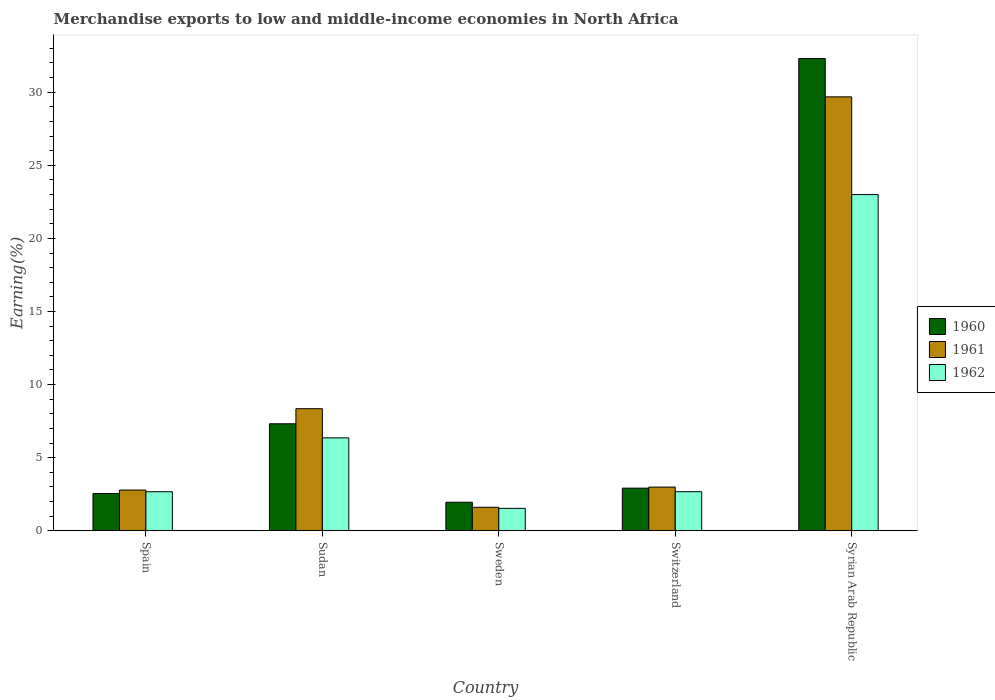How many groups of bars are there?
Provide a succinct answer. 5. Are the number of bars per tick equal to the number of legend labels?
Provide a succinct answer. Yes. Are the number of bars on each tick of the X-axis equal?
Provide a succinct answer. Yes. How many bars are there on the 3rd tick from the left?
Provide a short and direct response. 3. What is the label of the 5th group of bars from the left?
Provide a succinct answer. Syrian Arab Republic. In how many cases, is the number of bars for a given country not equal to the number of legend labels?
Ensure brevity in your answer.  0. What is the percentage of amount earned from merchandise exports in 1961 in Sweden?
Keep it short and to the point. 1.61. Across all countries, what is the maximum percentage of amount earned from merchandise exports in 1962?
Provide a succinct answer. 23. Across all countries, what is the minimum percentage of amount earned from merchandise exports in 1962?
Give a very brief answer. 1.53. In which country was the percentage of amount earned from merchandise exports in 1962 maximum?
Provide a short and direct response. Syrian Arab Republic. In which country was the percentage of amount earned from merchandise exports in 1962 minimum?
Your answer should be very brief. Sweden. What is the total percentage of amount earned from merchandise exports in 1962 in the graph?
Your response must be concise. 36.23. What is the difference between the percentage of amount earned from merchandise exports in 1960 in Sudan and that in Switzerland?
Provide a succinct answer. 4.4. What is the difference between the percentage of amount earned from merchandise exports in 1962 in Spain and the percentage of amount earned from merchandise exports in 1960 in Sweden?
Give a very brief answer. 0.72. What is the average percentage of amount earned from merchandise exports in 1962 per country?
Make the answer very short. 7.25. What is the difference between the percentage of amount earned from merchandise exports of/in 1962 and percentage of amount earned from merchandise exports of/in 1960 in Syrian Arab Republic?
Ensure brevity in your answer.  -9.31. What is the ratio of the percentage of amount earned from merchandise exports in 1961 in Sudan to that in Syrian Arab Republic?
Keep it short and to the point. 0.28. Is the percentage of amount earned from merchandise exports in 1960 in Switzerland less than that in Syrian Arab Republic?
Make the answer very short. Yes. What is the difference between the highest and the second highest percentage of amount earned from merchandise exports in 1962?
Offer a very short reply. -20.32. What is the difference between the highest and the lowest percentage of amount earned from merchandise exports in 1961?
Make the answer very short. 28.07. How many bars are there?
Offer a terse response. 15. Are all the bars in the graph horizontal?
Your answer should be very brief. No. Are the values on the major ticks of Y-axis written in scientific E-notation?
Make the answer very short. No. Does the graph contain any zero values?
Provide a succinct answer. No. How are the legend labels stacked?
Your answer should be very brief. Vertical. What is the title of the graph?
Provide a short and direct response. Merchandise exports to low and middle-income economies in North Africa. What is the label or title of the Y-axis?
Your response must be concise. Earning(%). What is the Earning(%) of 1960 in Spain?
Give a very brief answer. 2.55. What is the Earning(%) of 1961 in Spain?
Offer a very short reply. 2.79. What is the Earning(%) of 1962 in Spain?
Offer a terse response. 2.67. What is the Earning(%) of 1960 in Sudan?
Offer a terse response. 7.32. What is the Earning(%) of 1961 in Sudan?
Provide a succinct answer. 8.35. What is the Earning(%) of 1962 in Sudan?
Ensure brevity in your answer.  6.35. What is the Earning(%) in 1960 in Sweden?
Ensure brevity in your answer.  1.95. What is the Earning(%) in 1961 in Sweden?
Provide a succinct answer. 1.61. What is the Earning(%) of 1962 in Sweden?
Your response must be concise. 1.53. What is the Earning(%) in 1960 in Switzerland?
Offer a very short reply. 2.92. What is the Earning(%) of 1961 in Switzerland?
Offer a terse response. 2.99. What is the Earning(%) in 1962 in Switzerland?
Your response must be concise. 2.67. What is the Earning(%) in 1960 in Syrian Arab Republic?
Ensure brevity in your answer.  32.31. What is the Earning(%) of 1961 in Syrian Arab Republic?
Your answer should be very brief. 29.68. What is the Earning(%) in 1962 in Syrian Arab Republic?
Ensure brevity in your answer.  23. Across all countries, what is the maximum Earning(%) in 1960?
Provide a succinct answer. 32.31. Across all countries, what is the maximum Earning(%) in 1961?
Keep it short and to the point. 29.68. Across all countries, what is the maximum Earning(%) of 1962?
Your response must be concise. 23. Across all countries, what is the minimum Earning(%) of 1960?
Your answer should be compact. 1.95. Across all countries, what is the minimum Earning(%) of 1961?
Give a very brief answer. 1.61. Across all countries, what is the minimum Earning(%) in 1962?
Offer a terse response. 1.53. What is the total Earning(%) in 1960 in the graph?
Keep it short and to the point. 47.05. What is the total Earning(%) in 1961 in the graph?
Give a very brief answer. 45.42. What is the total Earning(%) in 1962 in the graph?
Keep it short and to the point. 36.23. What is the difference between the Earning(%) in 1960 in Spain and that in Sudan?
Give a very brief answer. -4.77. What is the difference between the Earning(%) of 1961 in Spain and that in Sudan?
Your answer should be compact. -5.57. What is the difference between the Earning(%) in 1962 in Spain and that in Sudan?
Keep it short and to the point. -3.68. What is the difference between the Earning(%) in 1960 in Spain and that in Sweden?
Provide a succinct answer. 0.6. What is the difference between the Earning(%) of 1961 in Spain and that in Sweden?
Provide a succinct answer. 1.18. What is the difference between the Earning(%) in 1962 in Spain and that in Sweden?
Your response must be concise. 1.14. What is the difference between the Earning(%) of 1960 in Spain and that in Switzerland?
Offer a terse response. -0.36. What is the difference between the Earning(%) of 1961 in Spain and that in Switzerland?
Your response must be concise. -0.2. What is the difference between the Earning(%) in 1962 in Spain and that in Switzerland?
Offer a very short reply. -0. What is the difference between the Earning(%) of 1960 in Spain and that in Syrian Arab Republic?
Provide a short and direct response. -29.76. What is the difference between the Earning(%) of 1961 in Spain and that in Syrian Arab Republic?
Provide a short and direct response. -26.9. What is the difference between the Earning(%) in 1962 in Spain and that in Syrian Arab Republic?
Your answer should be compact. -20.33. What is the difference between the Earning(%) in 1960 in Sudan and that in Sweden?
Your response must be concise. 5.37. What is the difference between the Earning(%) in 1961 in Sudan and that in Sweden?
Provide a succinct answer. 6.74. What is the difference between the Earning(%) of 1962 in Sudan and that in Sweden?
Offer a very short reply. 4.82. What is the difference between the Earning(%) in 1960 in Sudan and that in Switzerland?
Ensure brevity in your answer.  4.4. What is the difference between the Earning(%) of 1961 in Sudan and that in Switzerland?
Offer a terse response. 5.36. What is the difference between the Earning(%) in 1962 in Sudan and that in Switzerland?
Offer a terse response. 3.68. What is the difference between the Earning(%) of 1960 in Sudan and that in Syrian Arab Republic?
Your answer should be very brief. -24.99. What is the difference between the Earning(%) in 1961 in Sudan and that in Syrian Arab Republic?
Offer a very short reply. -21.33. What is the difference between the Earning(%) in 1962 in Sudan and that in Syrian Arab Republic?
Provide a short and direct response. -16.64. What is the difference between the Earning(%) of 1960 in Sweden and that in Switzerland?
Your response must be concise. -0.96. What is the difference between the Earning(%) in 1961 in Sweden and that in Switzerland?
Offer a very short reply. -1.38. What is the difference between the Earning(%) of 1962 in Sweden and that in Switzerland?
Keep it short and to the point. -1.14. What is the difference between the Earning(%) of 1960 in Sweden and that in Syrian Arab Republic?
Your response must be concise. -30.36. What is the difference between the Earning(%) of 1961 in Sweden and that in Syrian Arab Republic?
Your answer should be very brief. -28.07. What is the difference between the Earning(%) of 1962 in Sweden and that in Syrian Arab Republic?
Offer a very short reply. -21.47. What is the difference between the Earning(%) in 1960 in Switzerland and that in Syrian Arab Republic?
Offer a very short reply. -29.39. What is the difference between the Earning(%) of 1961 in Switzerland and that in Syrian Arab Republic?
Keep it short and to the point. -26.69. What is the difference between the Earning(%) of 1962 in Switzerland and that in Syrian Arab Republic?
Provide a succinct answer. -20.32. What is the difference between the Earning(%) in 1960 in Spain and the Earning(%) in 1961 in Sudan?
Give a very brief answer. -5.8. What is the difference between the Earning(%) in 1960 in Spain and the Earning(%) in 1962 in Sudan?
Your answer should be very brief. -3.8. What is the difference between the Earning(%) of 1961 in Spain and the Earning(%) of 1962 in Sudan?
Offer a very short reply. -3.57. What is the difference between the Earning(%) in 1960 in Spain and the Earning(%) in 1961 in Sweden?
Provide a short and direct response. 0.94. What is the difference between the Earning(%) in 1960 in Spain and the Earning(%) in 1962 in Sweden?
Give a very brief answer. 1.02. What is the difference between the Earning(%) in 1961 in Spain and the Earning(%) in 1962 in Sweden?
Make the answer very short. 1.25. What is the difference between the Earning(%) in 1960 in Spain and the Earning(%) in 1961 in Switzerland?
Provide a short and direct response. -0.44. What is the difference between the Earning(%) of 1960 in Spain and the Earning(%) of 1962 in Switzerland?
Ensure brevity in your answer.  -0.12. What is the difference between the Earning(%) in 1961 in Spain and the Earning(%) in 1962 in Switzerland?
Offer a very short reply. 0.11. What is the difference between the Earning(%) in 1960 in Spain and the Earning(%) in 1961 in Syrian Arab Republic?
Provide a succinct answer. -27.13. What is the difference between the Earning(%) in 1960 in Spain and the Earning(%) in 1962 in Syrian Arab Republic?
Give a very brief answer. -20.45. What is the difference between the Earning(%) of 1961 in Spain and the Earning(%) of 1962 in Syrian Arab Republic?
Offer a very short reply. -20.21. What is the difference between the Earning(%) in 1960 in Sudan and the Earning(%) in 1961 in Sweden?
Your response must be concise. 5.71. What is the difference between the Earning(%) in 1960 in Sudan and the Earning(%) in 1962 in Sweden?
Give a very brief answer. 5.79. What is the difference between the Earning(%) in 1961 in Sudan and the Earning(%) in 1962 in Sweden?
Your response must be concise. 6.82. What is the difference between the Earning(%) in 1960 in Sudan and the Earning(%) in 1961 in Switzerland?
Provide a succinct answer. 4.33. What is the difference between the Earning(%) of 1960 in Sudan and the Earning(%) of 1962 in Switzerland?
Your answer should be very brief. 4.65. What is the difference between the Earning(%) in 1961 in Sudan and the Earning(%) in 1962 in Switzerland?
Make the answer very short. 5.68. What is the difference between the Earning(%) of 1960 in Sudan and the Earning(%) of 1961 in Syrian Arab Republic?
Your answer should be very brief. -22.36. What is the difference between the Earning(%) in 1960 in Sudan and the Earning(%) in 1962 in Syrian Arab Republic?
Provide a succinct answer. -15.68. What is the difference between the Earning(%) of 1961 in Sudan and the Earning(%) of 1962 in Syrian Arab Republic?
Provide a short and direct response. -14.65. What is the difference between the Earning(%) of 1960 in Sweden and the Earning(%) of 1961 in Switzerland?
Your response must be concise. -1.04. What is the difference between the Earning(%) of 1960 in Sweden and the Earning(%) of 1962 in Switzerland?
Your response must be concise. -0.72. What is the difference between the Earning(%) in 1961 in Sweden and the Earning(%) in 1962 in Switzerland?
Offer a very short reply. -1.06. What is the difference between the Earning(%) in 1960 in Sweden and the Earning(%) in 1961 in Syrian Arab Republic?
Your answer should be compact. -27.73. What is the difference between the Earning(%) of 1960 in Sweden and the Earning(%) of 1962 in Syrian Arab Republic?
Keep it short and to the point. -21.05. What is the difference between the Earning(%) of 1961 in Sweden and the Earning(%) of 1962 in Syrian Arab Republic?
Provide a succinct answer. -21.39. What is the difference between the Earning(%) of 1960 in Switzerland and the Earning(%) of 1961 in Syrian Arab Republic?
Your answer should be very brief. -26.77. What is the difference between the Earning(%) of 1960 in Switzerland and the Earning(%) of 1962 in Syrian Arab Republic?
Make the answer very short. -20.08. What is the difference between the Earning(%) of 1961 in Switzerland and the Earning(%) of 1962 in Syrian Arab Republic?
Provide a succinct answer. -20.01. What is the average Earning(%) of 1960 per country?
Your response must be concise. 9.41. What is the average Earning(%) in 1961 per country?
Keep it short and to the point. 9.08. What is the average Earning(%) of 1962 per country?
Your response must be concise. 7.25. What is the difference between the Earning(%) in 1960 and Earning(%) in 1961 in Spain?
Your answer should be very brief. -0.23. What is the difference between the Earning(%) of 1960 and Earning(%) of 1962 in Spain?
Make the answer very short. -0.12. What is the difference between the Earning(%) in 1961 and Earning(%) in 1962 in Spain?
Your response must be concise. 0.11. What is the difference between the Earning(%) of 1960 and Earning(%) of 1961 in Sudan?
Make the answer very short. -1.03. What is the difference between the Earning(%) of 1960 and Earning(%) of 1962 in Sudan?
Provide a succinct answer. 0.96. What is the difference between the Earning(%) in 1961 and Earning(%) in 1962 in Sudan?
Provide a succinct answer. 2. What is the difference between the Earning(%) in 1960 and Earning(%) in 1961 in Sweden?
Provide a succinct answer. 0.34. What is the difference between the Earning(%) in 1960 and Earning(%) in 1962 in Sweden?
Your answer should be compact. 0.42. What is the difference between the Earning(%) in 1961 and Earning(%) in 1962 in Sweden?
Keep it short and to the point. 0.08. What is the difference between the Earning(%) in 1960 and Earning(%) in 1961 in Switzerland?
Keep it short and to the point. -0.07. What is the difference between the Earning(%) of 1960 and Earning(%) of 1962 in Switzerland?
Offer a terse response. 0.24. What is the difference between the Earning(%) of 1961 and Earning(%) of 1962 in Switzerland?
Give a very brief answer. 0.31. What is the difference between the Earning(%) in 1960 and Earning(%) in 1961 in Syrian Arab Republic?
Make the answer very short. 2.62. What is the difference between the Earning(%) of 1960 and Earning(%) of 1962 in Syrian Arab Republic?
Provide a short and direct response. 9.31. What is the difference between the Earning(%) of 1961 and Earning(%) of 1962 in Syrian Arab Republic?
Offer a very short reply. 6.68. What is the ratio of the Earning(%) in 1960 in Spain to that in Sudan?
Offer a terse response. 0.35. What is the ratio of the Earning(%) of 1961 in Spain to that in Sudan?
Your answer should be compact. 0.33. What is the ratio of the Earning(%) of 1962 in Spain to that in Sudan?
Your response must be concise. 0.42. What is the ratio of the Earning(%) in 1960 in Spain to that in Sweden?
Make the answer very short. 1.31. What is the ratio of the Earning(%) in 1961 in Spain to that in Sweden?
Your response must be concise. 1.73. What is the ratio of the Earning(%) of 1962 in Spain to that in Sweden?
Keep it short and to the point. 1.74. What is the ratio of the Earning(%) in 1960 in Spain to that in Switzerland?
Ensure brevity in your answer.  0.87. What is the ratio of the Earning(%) of 1961 in Spain to that in Switzerland?
Keep it short and to the point. 0.93. What is the ratio of the Earning(%) in 1960 in Spain to that in Syrian Arab Republic?
Offer a terse response. 0.08. What is the ratio of the Earning(%) in 1961 in Spain to that in Syrian Arab Republic?
Provide a succinct answer. 0.09. What is the ratio of the Earning(%) of 1962 in Spain to that in Syrian Arab Republic?
Provide a short and direct response. 0.12. What is the ratio of the Earning(%) in 1960 in Sudan to that in Sweden?
Give a very brief answer. 3.75. What is the ratio of the Earning(%) in 1961 in Sudan to that in Sweden?
Provide a short and direct response. 5.19. What is the ratio of the Earning(%) of 1962 in Sudan to that in Sweden?
Offer a terse response. 4.14. What is the ratio of the Earning(%) of 1960 in Sudan to that in Switzerland?
Keep it short and to the point. 2.51. What is the ratio of the Earning(%) of 1961 in Sudan to that in Switzerland?
Provide a short and direct response. 2.79. What is the ratio of the Earning(%) of 1962 in Sudan to that in Switzerland?
Your response must be concise. 2.38. What is the ratio of the Earning(%) in 1960 in Sudan to that in Syrian Arab Republic?
Give a very brief answer. 0.23. What is the ratio of the Earning(%) of 1961 in Sudan to that in Syrian Arab Republic?
Make the answer very short. 0.28. What is the ratio of the Earning(%) in 1962 in Sudan to that in Syrian Arab Republic?
Your response must be concise. 0.28. What is the ratio of the Earning(%) in 1960 in Sweden to that in Switzerland?
Offer a terse response. 0.67. What is the ratio of the Earning(%) of 1961 in Sweden to that in Switzerland?
Make the answer very short. 0.54. What is the ratio of the Earning(%) in 1962 in Sweden to that in Switzerland?
Your answer should be very brief. 0.57. What is the ratio of the Earning(%) of 1960 in Sweden to that in Syrian Arab Republic?
Offer a terse response. 0.06. What is the ratio of the Earning(%) in 1961 in Sweden to that in Syrian Arab Republic?
Make the answer very short. 0.05. What is the ratio of the Earning(%) in 1962 in Sweden to that in Syrian Arab Republic?
Your answer should be very brief. 0.07. What is the ratio of the Earning(%) in 1960 in Switzerland to that in Syrian Arab Republic?
Make the answer very short. 0.09. What is the ratio of the Earning(%) in 1961 in Switzerland to that in Syrian Arab Republic?
Give a very brief answer. 0.1. What is the ratio of the Earning(%) in 1962 in Switzerland to that in Syrian Arab Republic?
Your answer should be compact. 0.12. What is the difference between the highest and the second highest Earning(%) of 1960?
Keep it short and to the point. 24.99. What is the difference between the highest and the second highest Earning(%) in 1961?
Give a very brief answer. 21.33. What is the difference between the highest and the second highest Earning(%) of 1962?
Ensure brevity in your answer.  16.64. What is the difference between the highest and the lowest Earning(%) in 1960?
Your answer should be very brief. 30.36. What is the difference between the highest and the lowest Earning(%) of 1961?
Keep it short and to the point. 28.07. What is the difference between the highest and the lowest Earning(%) in 1962?
Give a very brief answer. 21.47. 